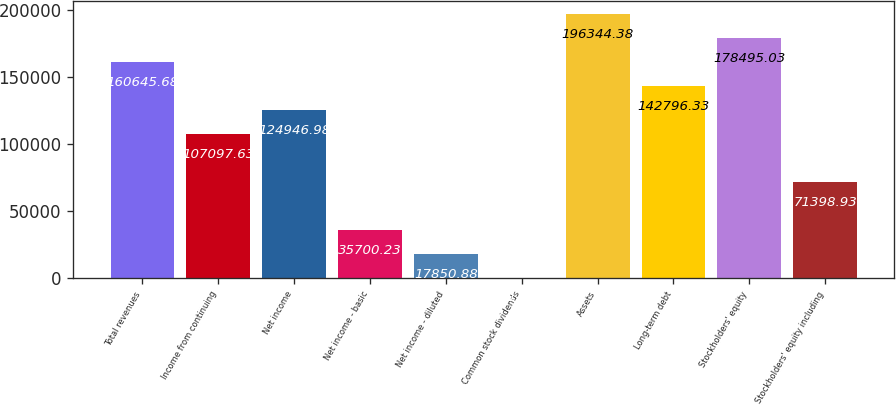Convert chart. <chart><loc_0><loc_0><loc_500><loc_500><bar_chart><fcel>Total revenues<fcel>Income from continuing<fcel>Net income<fcel>Net income - basic<fcel>Net income - diluted<fcel>Common stock dividends<fcel>Assets<fcel>Long-term debt<fcel>Stockholders' equity<fcel>Stockholders' equity including<nl><fcel>160646<fcel>107098<fcel>124947<fcel>35700.2<fcel>17850.9<fcel>1.53<fcel>196344<fcel>142796<fcel>178495<fcel>71398.9<nl></chart> 